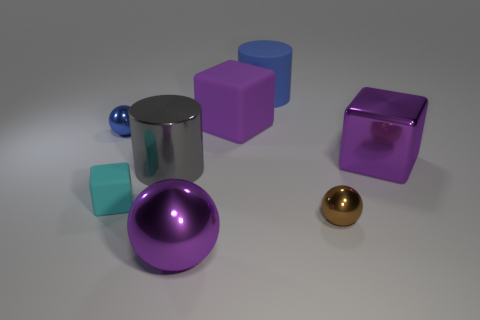There is a cyan object that is the same shape as the purple matte object; what material is it?
Provide a short and direct response. Rubber. How many other objects are the same color as the large shiny ball?
Make the answer very short. 2. Are there more big blue matte objects that are in front of the matte cylinder than small yellow cylinders?
Ensure brevity in your answer.  No. Does the large rubber cylinder have the same color as the metallic cube?
Offer a terse response. No. How many other rubber things are the same shape as the tiny blue object?
Make the answer very short. 0. There is a blue object that is the same material as the cyan cube; what is its size?
Provide a succinct answer. Large. What color is the big shiny object that is behind the brown metallic thing and on the left side of the brown metallic ball?
Make the answer very short. Gray. What number of balls are the same size as the cyan object?
Make the answer very short. 2. What is the size of the matte cube that is the same color as the big shiny sphere?
Provide a succinct answer. Large. What size is the cube that is both to the left of the large blue object and in front of the large matte cube?
Your answer should be very brief. Small. 